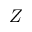Convert formula to latex. <formula><loc_0><loc_0><loc_500><loc_500>Z</formula> 